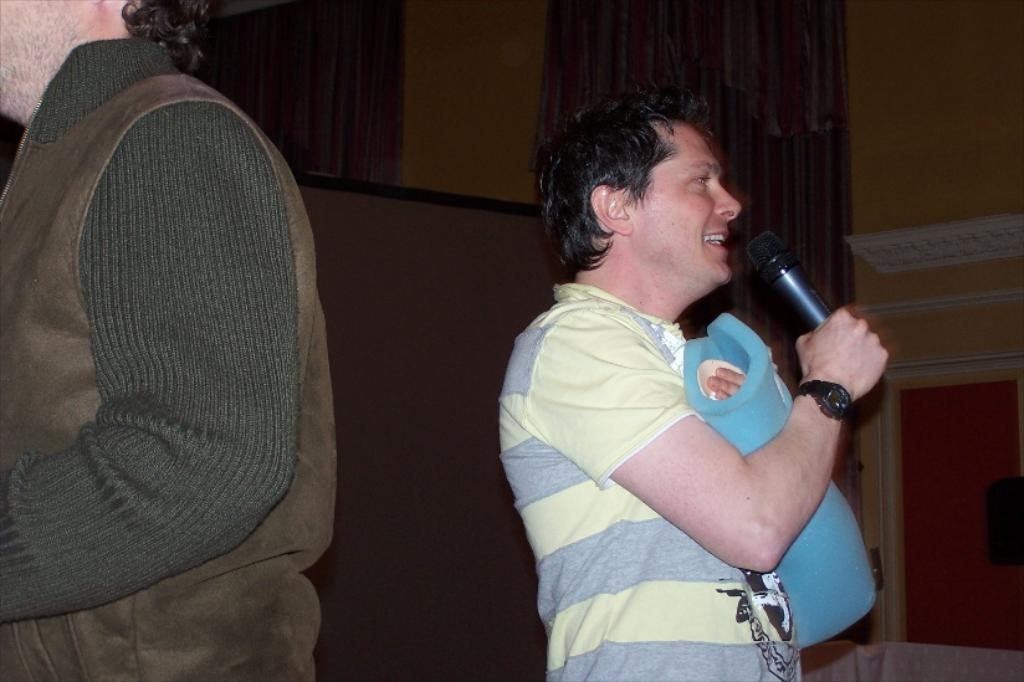What is the man in the image holding? The man is holding a microphone in the image. What is the man with the microphone doing? The man is talking. Can you describe the other person in the image? There is another man on the left side of the image. What can be seen in the background of the image? There is a wall in the background of the image. What type of comb is the man using to style his hair in the image? There is no comb visible in the image, and the man's hair is not being styled. 